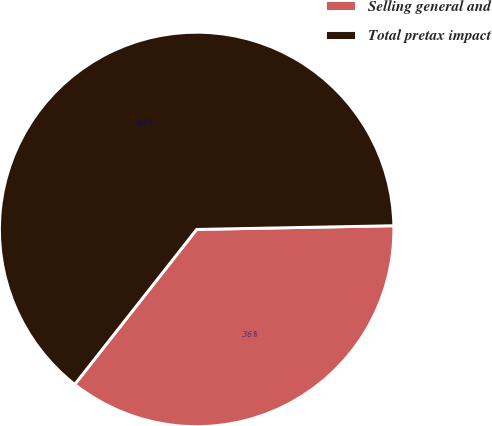Convert chart. <chart><loc_0><loc_0><loc_500><loc_500><pie_chart><fcel>Selling general and<fcel>Total pretax impact<nl><fcel>35.91%<fcel>64.09%<nl></chart> 